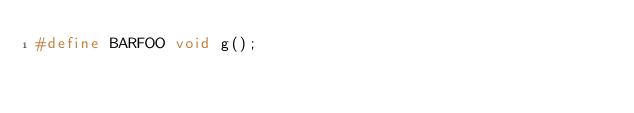<code> <loc_0><loc_0><loc_500><loc_500><_C_>#define BARFOO void g();
</code> 